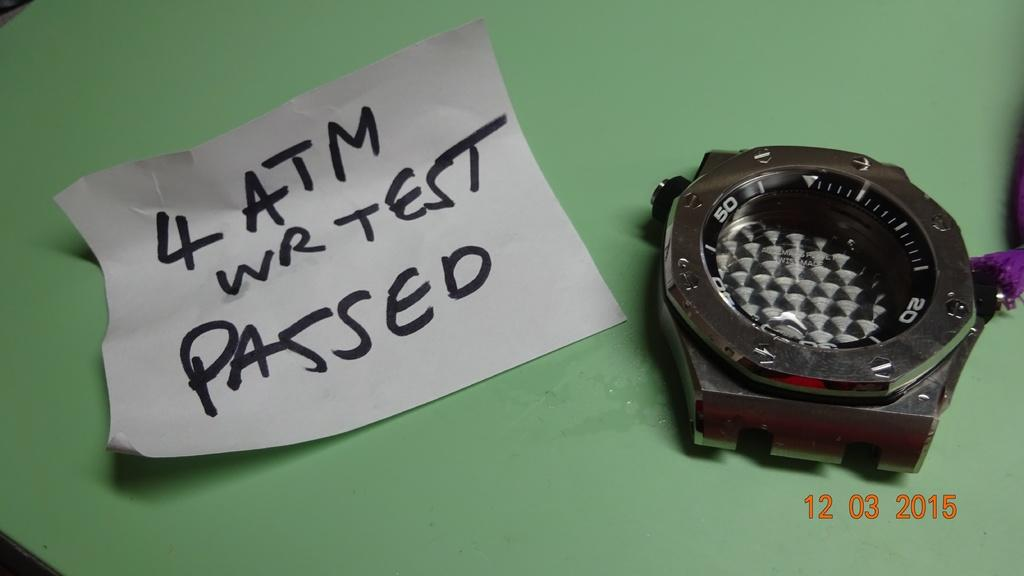Provide a one-sentence caption for the provided image. A watch sits next to a note with "4 ATM" written on it. 